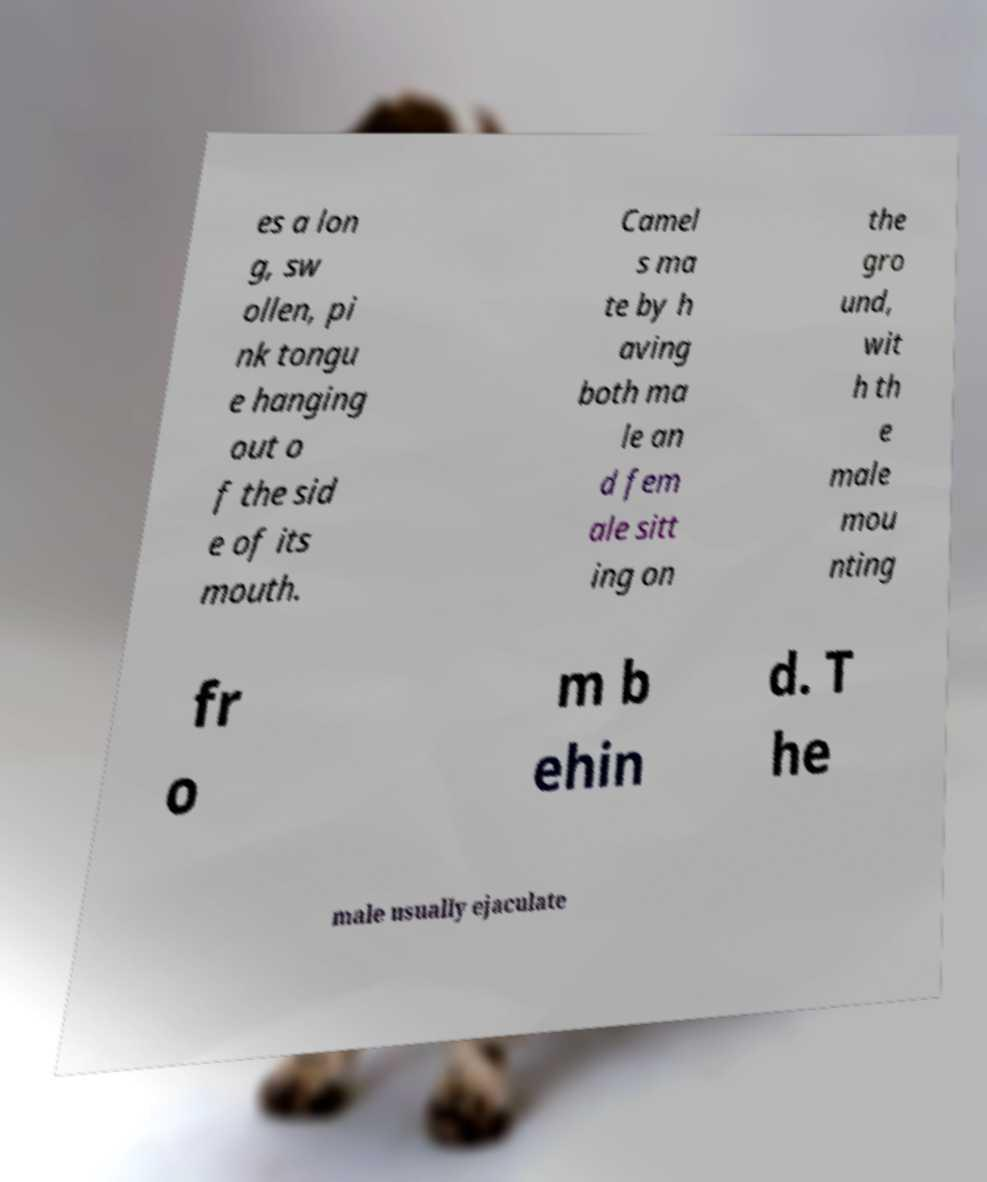I need the written content from this picture converted into text. Can you do that? es a lon g, sw ollen, pi nk tongu e hanging out o f the sid e of its mouth. Camel s ma te by h aving both ma le an d fem ale sitt ing on the gro und, wit h th e male mou nting fr o m b ehin d. T he male usually ejaculate 